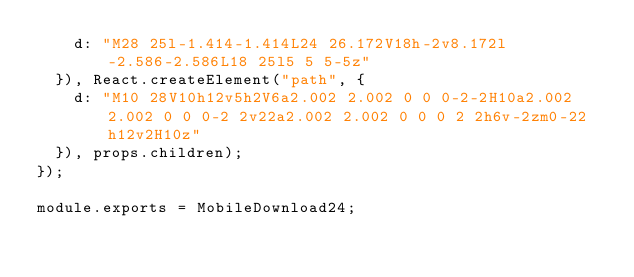Convert code to text. <code><loc_0><loc_0><loc_500><loc_500><_JavaScript_>    d: "M28 25l-1.414-1.414L24 26.172V18h-2v8.172l-2.586-2.586L18 25l5 5 5-5z"
  }), React.createElement("path", {
    d: "M10 28V10h12v5h2V6a2.002 2.002 0 0 0-2-2H10a2.002 2.002 0 0 0-2 2v22a2.002 2.002 0 0 0 2 2h6v-2zm0-22h12v2H10z"
  }), props.children);
});

module.exports = MobileDownload24;
</code> 